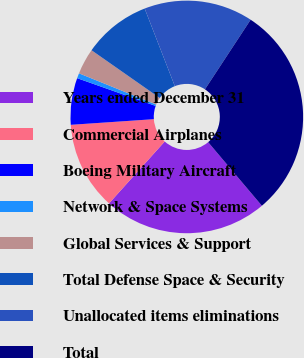<chart> <loc_0><loc_0><loc_500><loc_500><pie_chart><fcel>Years ended December 31<fcel>Commercial Airplanes<fcel>Boeing Military Aircraft<fcel>Network & Space Systems<fcel>Global Services & Support<fcel>Total Defense Space & Security<fcel>Unallocated items eliminations<fcel>Total<nl><fcel>22.83%<fcel>12.26%<fcel>6.49%<fcel>0.71%<fcel>3.6%<fcel>9.38%<fcel>15.15%<fcel>29.59%<nl></chart> 